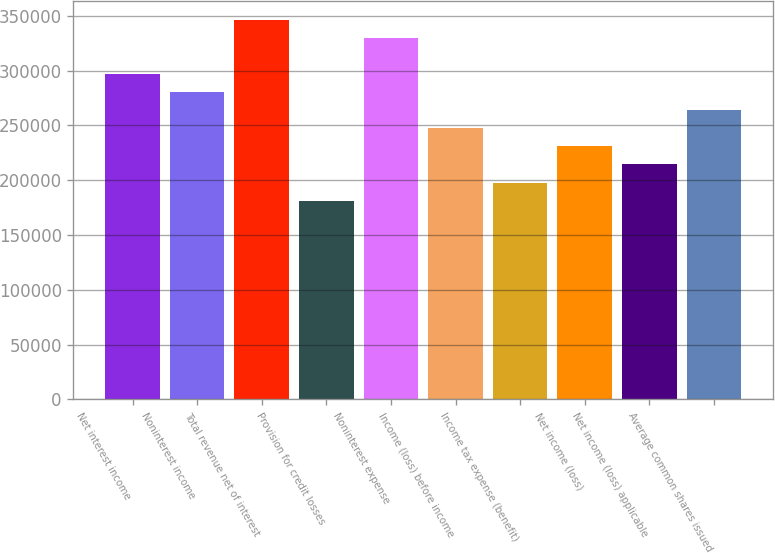Convert chart. <chart><loc_0><loc_0><loc_500><loc_500><bar_chart><fcel>Net interest income<fcel>Noninterest income<fcel>Total revenue net of interest<fcel>Provision for credit losses<fcel>Noninterest expense<fcel>Income (loss) before income<fcel>Income tax expense (benefit)<fcel>Net income (loss)<fcel>Net income (loss) applicable<fcel>Average common shares issued<nl><fcel>296845<fcel>280354<fcel>346319<fcel>181405<fcel>329828<fcel>247371<fcel>197897<fcel>230880<fcel>214388<fcel>263862<nl></chart> 